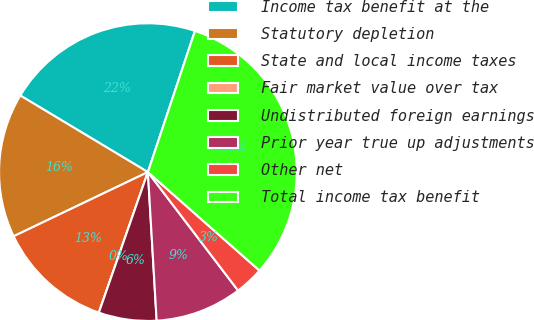Convert chart. <chart><loc_0><loc_0><loc_500><loc_500><pie_chart><fcel>Income tax benefit at the<fcel>Statutory depletion<fcel>State and local income taxes<fcel>Fair market value over tax<fcel>Undistributed foreign earnings<fcel>Prior year true up adjustments<fcel>Other net<fcel>Total income tax benefit<nl><fcel>21.52%<fcel>15.7%<fcel>12.56%<fcel>0.0%<fcel>6.28%<fcel>9.42%<fcel>3.14%<fcel>31.39%<nl></chart> 